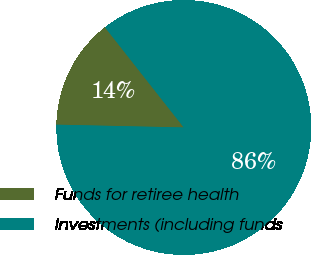Convert chart. <chart><loc_0><loc_0><loc_500><loc_500><pie_chart><fcel>Funds for retiree health<fcel>Investments (including funds<nl><fcel>14.04%<fcel>85.96%<nl></chart> 